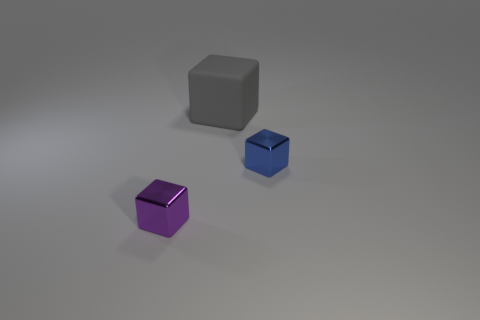Does the block in front of the small blue object have the same material as the tiny blue object?
Your answer should be very brief. Yes. How many other objects are there of the same shape as the blue thing?
Make the answer very short. 2. There is a small metallic thing to the left of the shiny object that is right of the gray thing; how many large things are in front of it?
Your response must be concise. 0. The tiny shiny object that is behind the purple object is what color?
Provide a succinct answer. Blue. There is a metal cube that is behind the small purple shiny thing; is it the same color as the matte thing?
Your answer should be compact. No. What size is the other blue thing that is the same shape as the large matte object?
Provide a short and direct response. Small. Is there any other thing that has the same size as the purple object?
Ensure brevity in your answer.  Yes. There is a tiny block that is in front of the shiny object that is behind the thing that is in front of the small blue metal cube; what is its material?
Offer a terse response. Metal. Are there more small purple blocks that are on the left side of the blue block than purple metallic objects that are right of the small purple shiny block?
Give a very brief answer. Yes. Is the gray cube the same size as the purple thing?
Provide a short and direct response. No. 